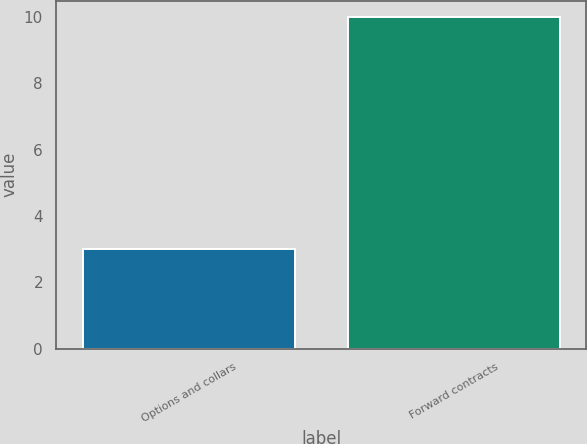Convert chart to OTSL. <chart><loc_0><loc_0><loc_500><loc_500><bar_chart><fcel>Options and collars<fcel>Forward contracts<nl><fcel>3<fcel>10<nl></chart> 